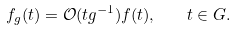<formula> <loc_0><loc_0><loc_500><loc_500>f _ { g } ( t ) = \mathcal { O } ( t g ^ { - 1 } ) f ( t ) , \quad t \in G .</formula> 